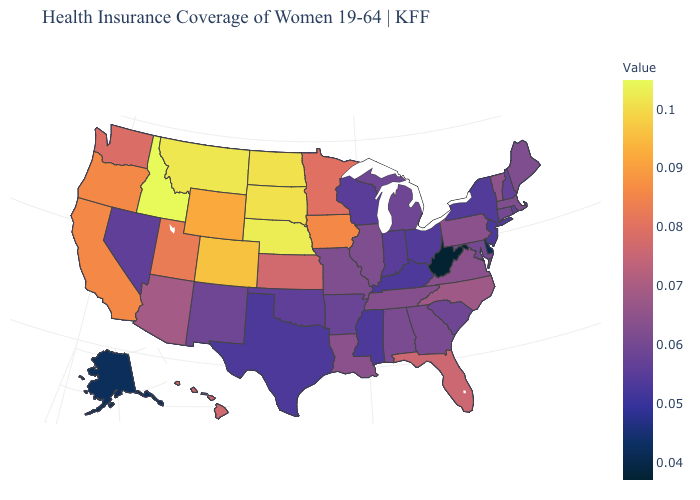Which states have the lowest value in the West?
Give a very brief answer. Alaska. Does Illinois have the lowest value in the MidWest?
Write a very short answer. No. Does West Virginia have the lowest value in the USA?
Keep it brief. Yes. 